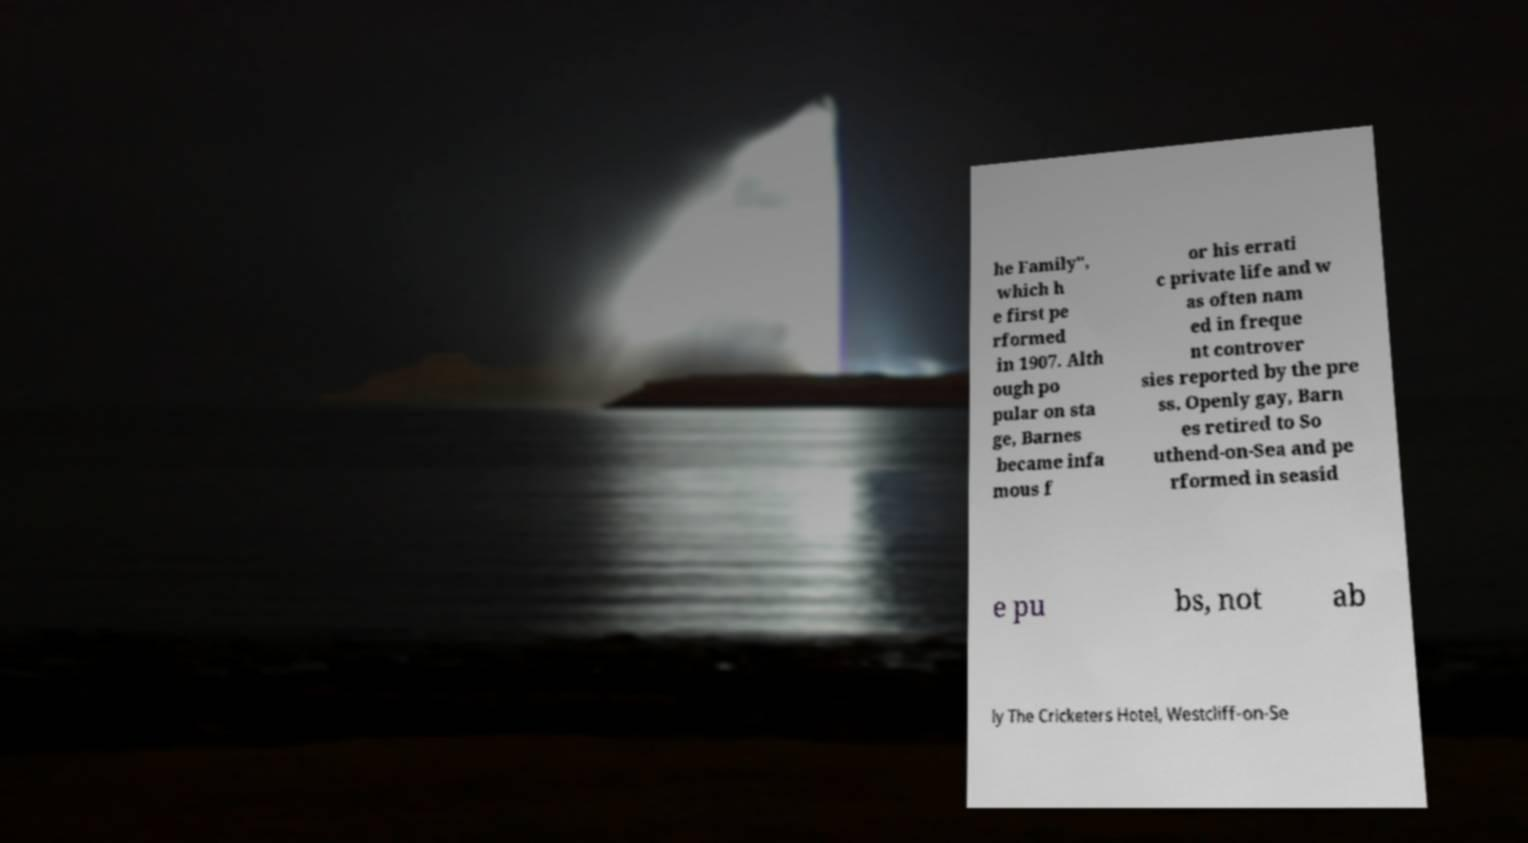Could you assist in decoding the text presented in this image and type it out clearly? he Family", which h e first pe rformed in 1907. Alth ough po pular on sta ge, Barnes became infa mous f or his errati c private life and w as often nam ed in freque nt controver sies reported by the pre ss. Openly gay, Barn es retired to So uthend-on-Sea and pe rformed in seasid e pu bs, not ab ly The Cricketers Hotel, Westcliff-on-Se 